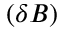Convert formula to latex. <formula><loc_0><loc_0><loc_500><loc_500>( \delta B )</formula> 